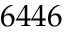<formula> <loc_0><loc_0><loc_500><loc_500>6 4 4 6</formula> 